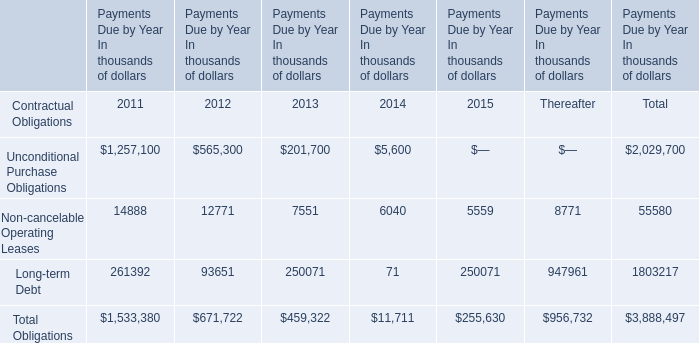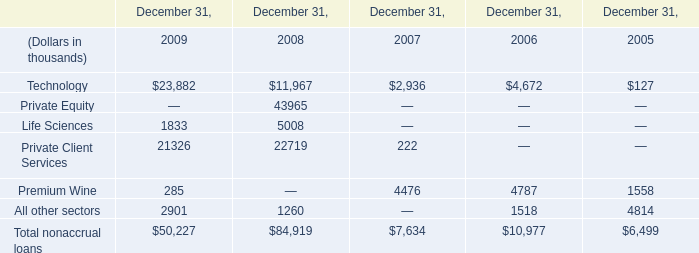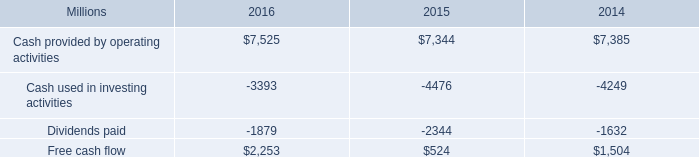What is the sum of Technology of December 31, 2008, and Cash used in investing activities of 2016 ? 
Computations: (11967.0 + 3393.0)
Answer: 15360.0. 